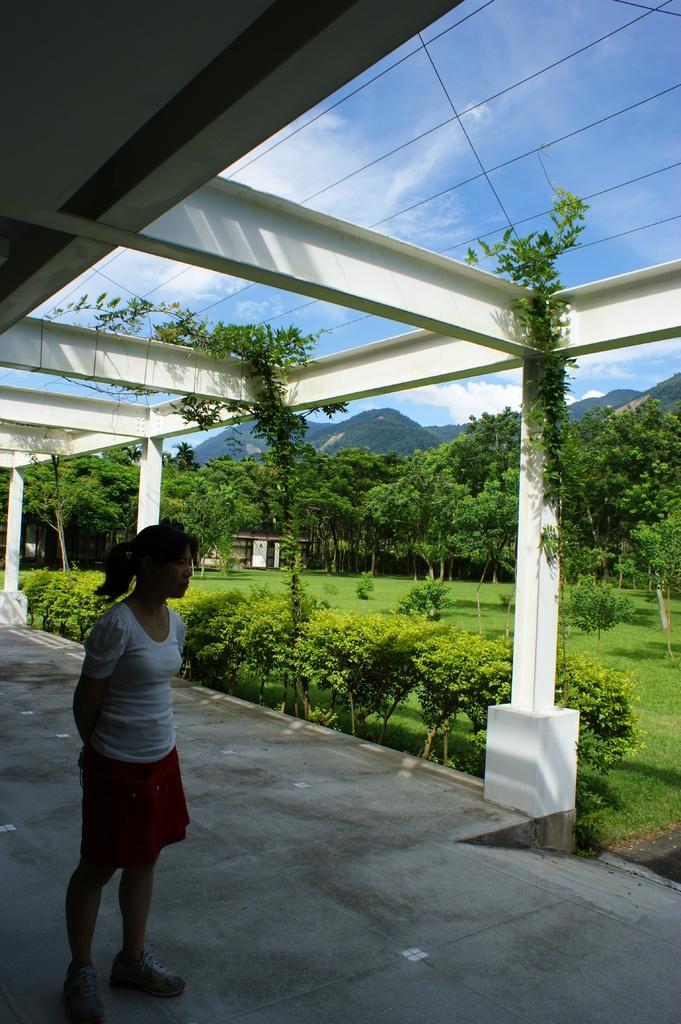Describe this image in one or two sentences. There is one person standing on the left side is wearing white color t shirt, and there are some plants and trees in the background. There are some mountains are present behind these trees, and there is a cloudy sky at the top of this image. We can see there are metal pillars on the left side of this image. 